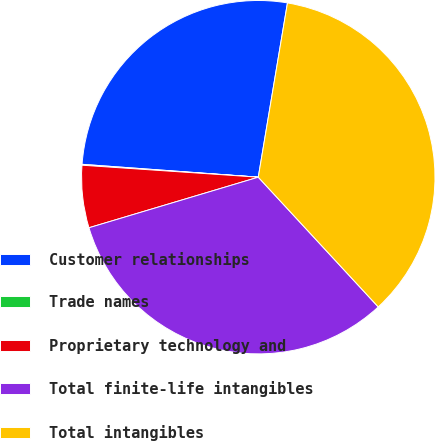Convert chart. <chart><loc_0><loc_0><loc_500><loc_500><pie_chart><fcel>Customer relationships<fcel>Trade names<fcel>Proprietary technology and<fcel>Total finite-life intangibles<fcel>Total intangibles<nl><fcel>26.48%<fcel>0.08%<fcel>5.7%<fcel>32.26%<fcel>35.48%<nl></chart> 